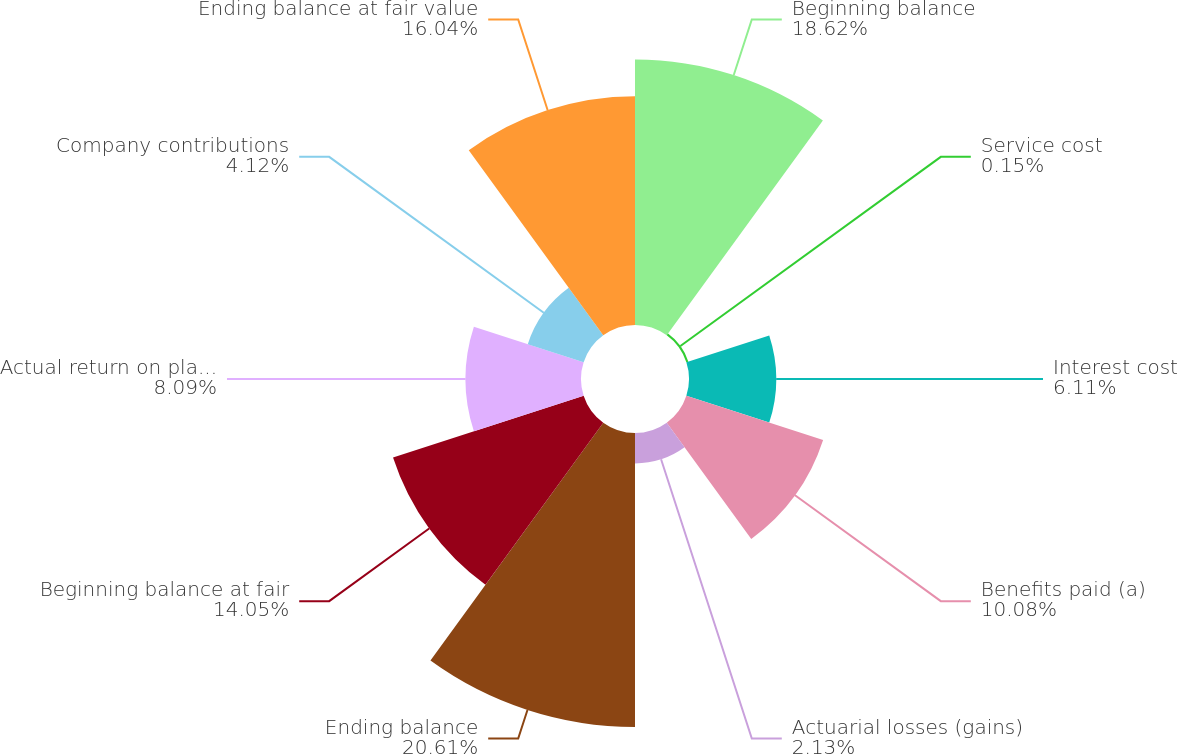Convert chart to OTSL. <chart><loc_0><loc_0><loc_500><loc_500><pie_chart><fcel>Beginning balance<fcel>Service cost<fcel>Interest cost<fcel>Benefits paid (a)<fcel>Actuarial losses (gains)<fcel>Ending balance<fcel>Beginning balance at fair<fcel>Actual return on plan assets<fcel>Company contributions<fcel>Ending balance at fair value<nl><fcel>18.62%<fcel>0.15%<fcel>6.11%<fcel>10.08%<fcel>2.13%<fcel>20.61%<fcel>14.05%<fcel>8.09%<fcel>4.12%<fcel>16.04%<nl></chart> 